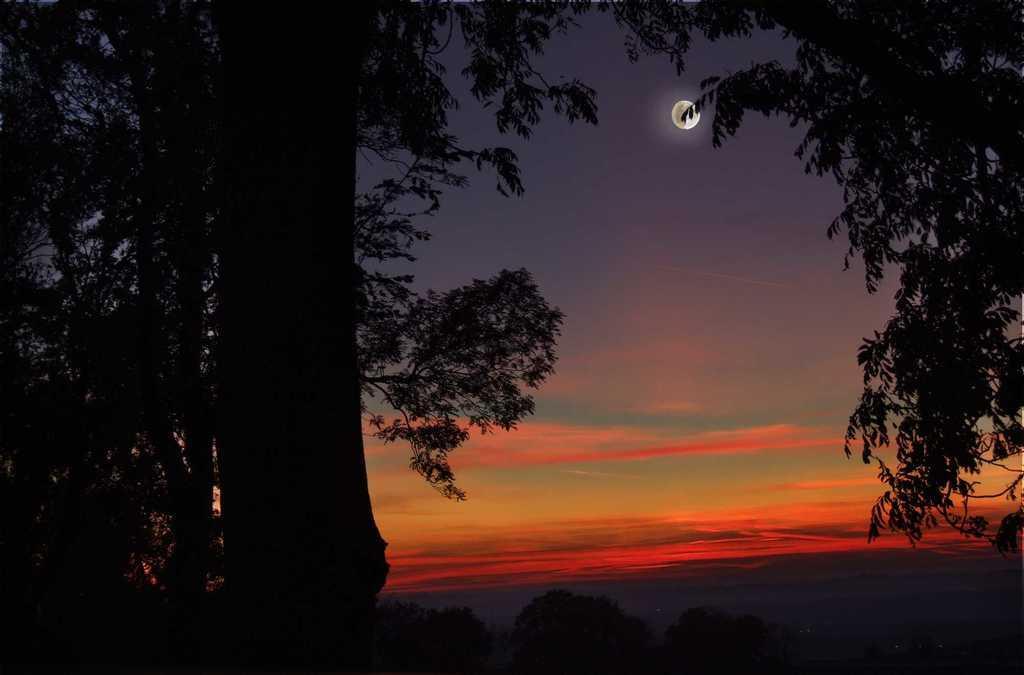Can you describe this image briefly? In this image there are trees and there is a moon in the sky. 